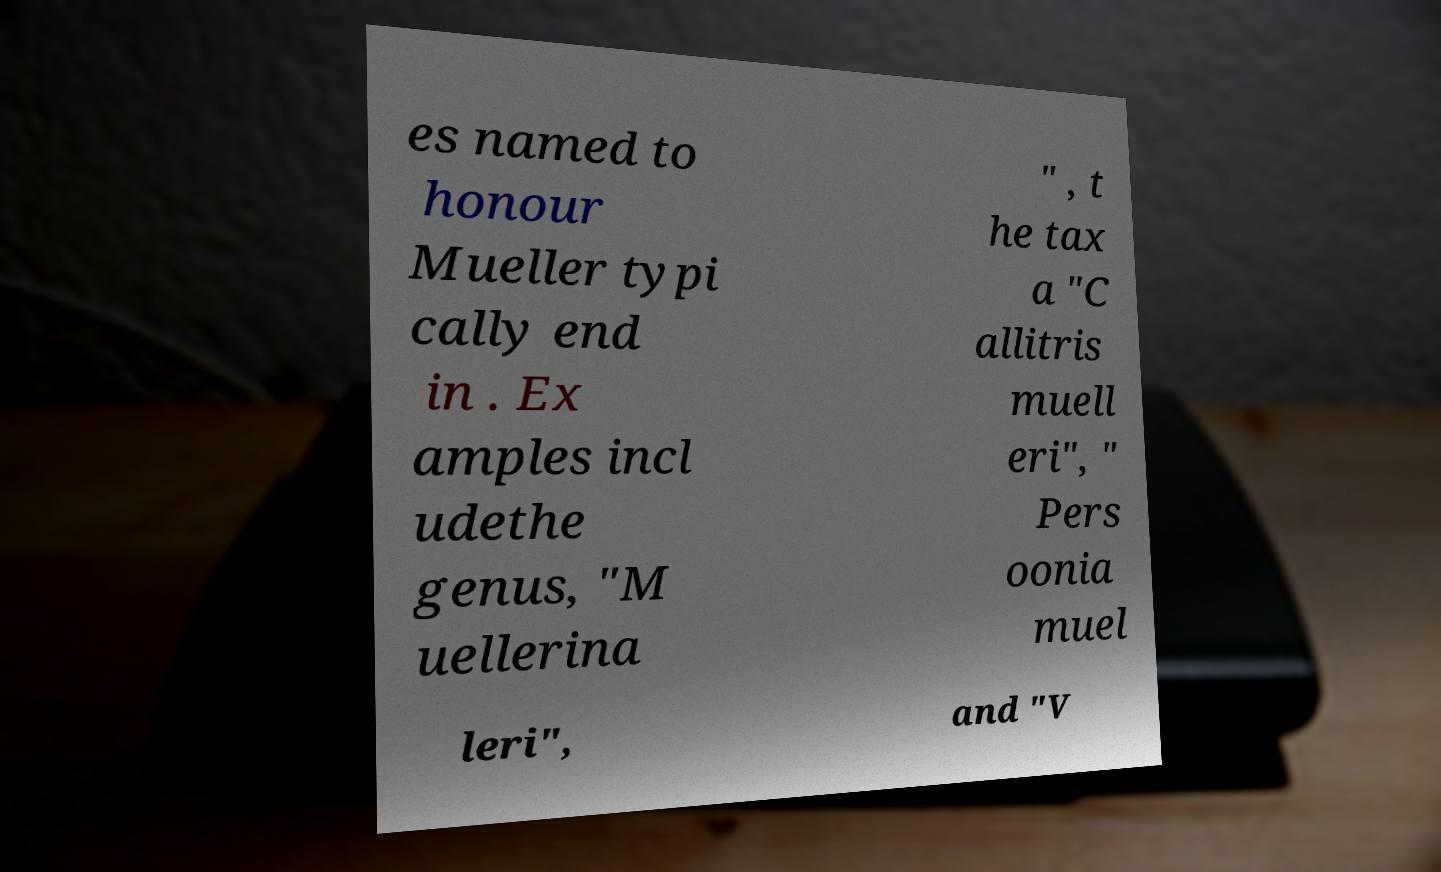Can you read and provide the text displayed in the image?This photo seems to have some interesting text. Can you extract and type it out for me? es named to honour Mueller typi cally end in . Ex amples incl udethe genus, "M uellerina " , t he tax a "C allitris muell eri", " Pers oonia muel leri", and "V 